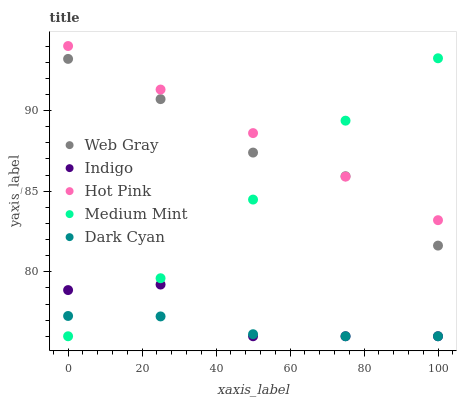Does Dark Cyan have the minimum area under the curve?
Answer yes or no. Yes. Does Hot Pink have the maximum area under the curve?
Answer yes or no. Yes. Does Web Gray have the minimum area under the curve?
Answer yes or no. No. Does Web Gray have the maximum area under the curve?
Answer yes or no. No. Is Hot Pink the smoothest?
Answer yes or no. Yes. Is Indigo the roughest?
Answer yes or no. Yes. Is Dark Cyan the smoothest?
Answer yes or no. No. Is Dark Cyan the roughest?
Answer yes or no. No. Does Medium Mint have the lowest value?
Answer yes or no. Yes. Does Web Gray have the lowest value?
Answer yes or no. No. Does Hot Pink have the highest value?
Answer yes or no. Yes. Does Web Gray have the highest value?
Answer yes or no. No. Is Dark Cyan less than Web Gray?
Answer yes or no. Yes. Is Hot Pink greater than Indigo?
Answer yes or no. Yes. Does Dark Cyan intersect Medium Mint?
Answer yes or no. Yes. Is Dark Cyan less than Medium Mint?
Answer yes or no. No. Is Dark Cyan greater than Medium Mint?
Answer yes or no. No. Does Dark Cyan intersect Web Gray?
Answer yes or no. No. 